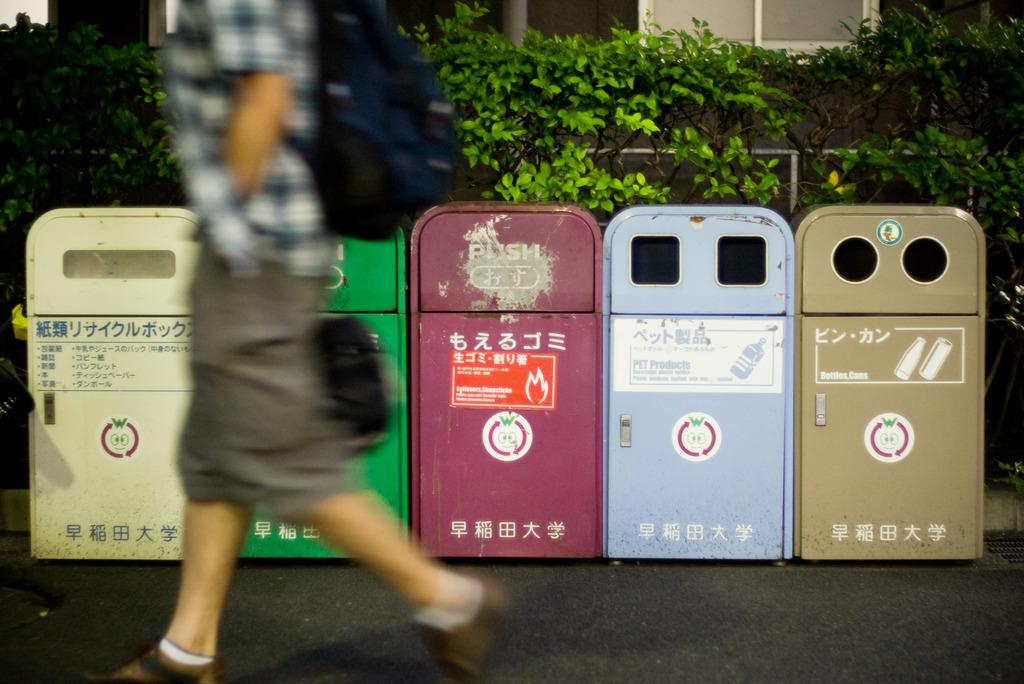Are these bins part of an asian university?
Make the answer very short. Unanswerable. What colour is the middle bin?
Your answer should be very brief. Answering does not require reading text in the image. 